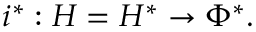Convert formula to latex. <formula><loc_0><loc_0><loc_500><loc_500>i ^ { * } \colon H = H ^ { * } \to \Phi ^ { * } .</formula> 